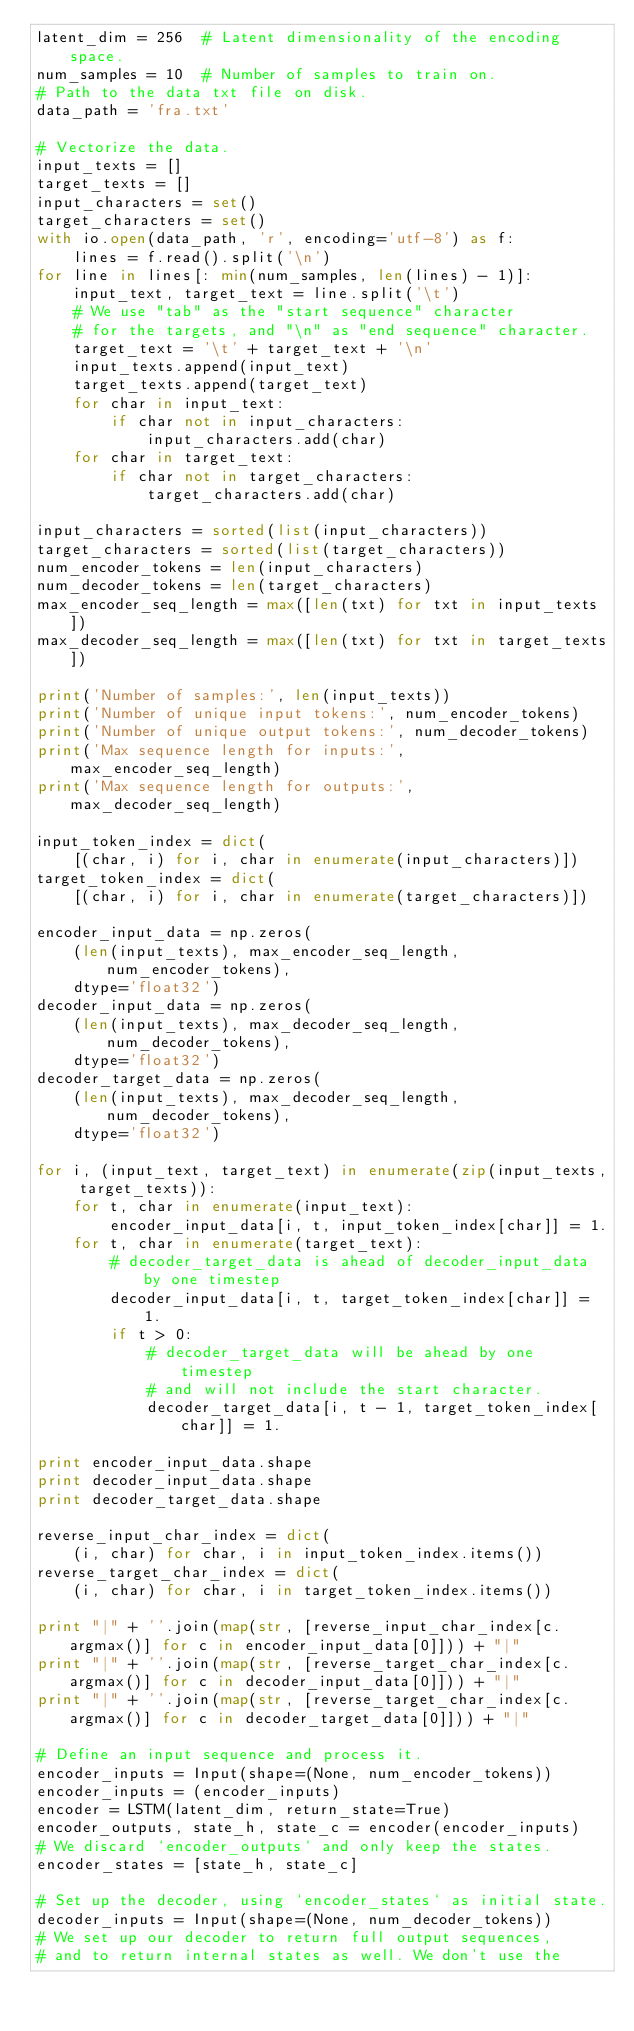Convert code to text. <code><loc_0><loc_0><loc_500><loc_500><_Python_>latent_dim = 256  # Latent dimensionality of the encoding space.
num_samples = 10  # Number of samples to train on.
# Path to the data txt file on disk.
data_path = 'fra.txt'

# Vectorize the data.
input_texts = []
target_texts = []
input_characters = set()
target_characters = set()
with io.open(data_path, 'r', encoding='utf-8') as f:
    lines = f.read().split('\n')
for line in lines[: min(num_samples, len(lines) - 1)]:
    input_text, target_text = line.split('\t')
    # We use "tab" as the "start sequence" character
    # for the targets, and "\n" as "end sequence" character.
    target_text = '\t' + target_text + '\n'
    input_texts.append(input_text)
    target_texts.append(target_text)
    for char in input_text:
        if char not in input_characters:
            input_characters.add(char)
    for char in target_text:
        if char not in target_characters:
            target_characters.add(char)

input_characters = sorted(list(input_characters))
target_characters = sorted(list(target_characters))
num_encoder_tokens = len(input_characters)
num_decoder_tokens = len(target_characters)
max_encoder_seq_length = max([len(txt) for txt in input_texts])
max_decoder_seq_length = max([len(txt) for txt in target_texts])

print('Number of samples:', len(input_texts))
print('Number of unique input tokens:', num_encoder_tokens)
print('Number of unique output tokens:', num_decoder_tokens)
print('Max sequence length for inputs:', max_encoder_seq_length)
print('Max sequence length for outputs:', max_decoder_seq_length)

input_token_index = dict(
    [(char, i) for i, char in enumerate(input_characters)])
target_token_index = dict(
    [(char, i) for i, char in enumerate(target_characters)])

encoder_input_data = np.zeros(
    (len(input_texts), max_encoder_seq_length, num_encoder_tokens),
    dtype='float32')
decoder_input_data = np.zeros(
    (len(input_texts), max_decoder_seq_length, num_decoder_tokens),
    dtype='float32')
decoder_target_data = np.zeros(
    (len(input_texts), max_decoder_seq_length, num_decoder_tokens),
    dtype='float32')

for i, (input_text, target_text) in enumerate(zip(input_texts, target_texts)):
    for t, char in enumerate(input_text):
        encoder_input_data[i, t, input_token_index[char]] = 1.
    for t, char in enumerate(target_text):
        # decoder_target_data is ahead of decoder_input_data by one timestep
        decoder_input_data[i, t, target_token_index[char]] = 1.
        if t > 0:
            # decoder_target_data will be ahead by one timestep
            # and will not include the start character.
            decoder_target_data[i, t - 1, target_token_index[char]] = 1.

print encoder_input_data.shape
print decoder_input_data.shape
print decoder_target_data.shape

reverse_input_char_index = dict(
    (i, char) for char, i in input_token_index.items())
reverse_target_char_index = dict(
    (i, char) for char, i in target_token_index.items())

print "|" + ''.join(map(str, [reverse_input_char_index[c.argmax()] for c in encoder_input_data[0]])) + "|"
print "|" + ''.join(map(str, [reverse_target_char_index[c.argmax()] for c in decoder_input_data[0]])) + "|"
print "|" + ''.join(map(str, [reverse_target_char_index[c.argmax()] for c in decoder_target_data[0]])) + "|"

# Define an input sequence and process it.
encoder_inputs = Input(shape=(None, num_encoder_tokens))
encoder_inputs = (encoder_inputs)
encoder = LSTM(latent_dim, return_state=True)
encoder_outputs, state_h, state_c = encoder(encoder_inputs)
# We discard `encoder_outputs` and only keep the states.
encoder_states = [state_h, state_c]

# Set up the decoder, using `encoder_states` as initial state.
decoder_inputs = Input(shape=(None, num_decoder_tokens))
# We set up our decoder to return full output sequences,
# and to return internal states as well. We don't use the</code> 